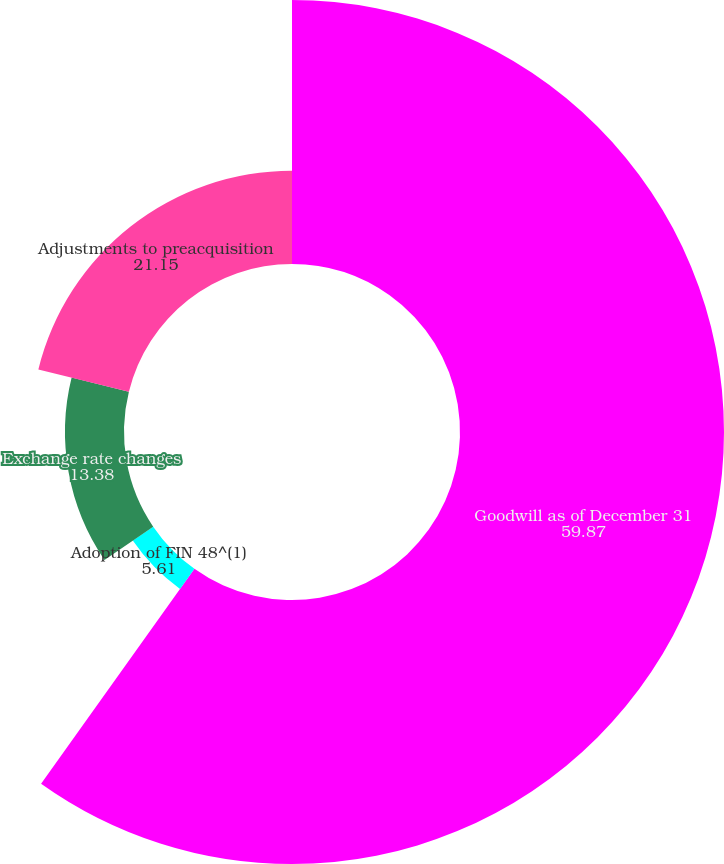Convert chart. <chart><loc_0><loc_0><loc_500><loc_500><pie_chart><fcel>Goodwill as of December 31<fcel>Adoption of FIN 48^(1)<fcel>Exchange rate changes<fcel>Adjustments to preacquisition<nl><fcel>59.87%<fcel>5.61%<fcel>13.38%<fcel>21.15%<nl></chart> 